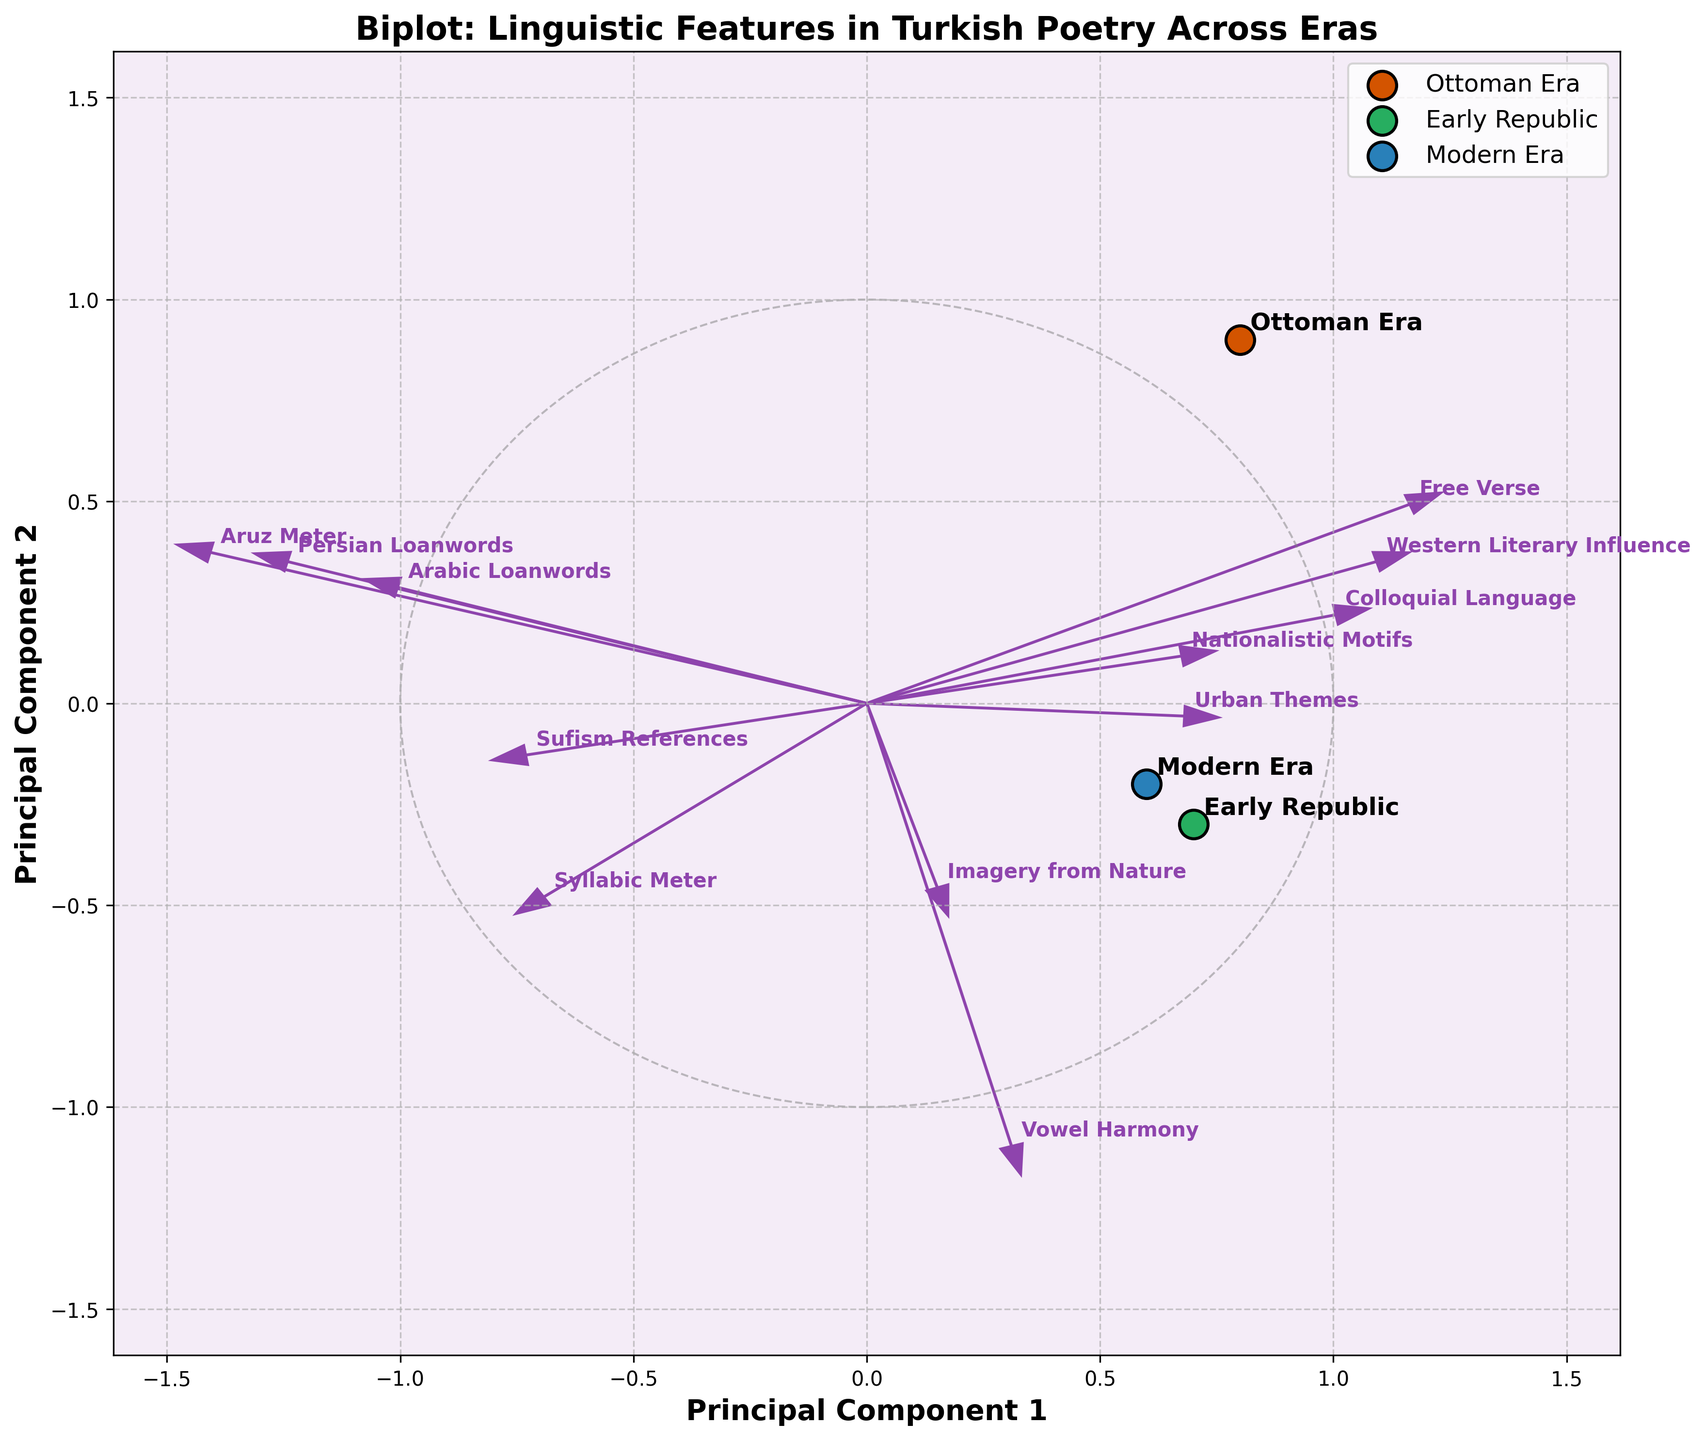What is the main title of the biplot? The main title is located at the top of the figure and is typically the most prominent text.
Answer: Biplot: Linguistic Features in Turkish Poetry Across Eras Which eras are represented by the three data points in the biplot? The three eras can be identified by looking at the labels near the large data points in the plot, marked by different colors.
Answer: Ottoman Era, Early Republic, Modern Era Which feature vector points in the direction of "Western Literary Influence"? The feature vectors are indicated by arrows, each labeled with a feature name. The "Western Literary Influence" arrow will point in a specific direction on the plot.
Answer: The arrow pointing towards the upper right quadrant Which era has the highest association with "Syllabic Meter"? To determine this, locate the data point for "Syllabic Meter" and see which era's data point is closest to it.
Answer: Ottoman Era How does "Urban Themes" change from the Ottoman Era to the Modern Era? Track the relative position of "Urban Themes" in respect to the Ottoman and Modern Era data points, indicated by its feature vector.
Answer: It increases, moving from a negative value in the Ottoman Era to a positive value in the Modern Era Which feature shows the most significant departure from traditional to modern times? Observe the lengths and directions of feature vectors to see which one moves most drastically from one end to another relative to the era points.
Answer: Aruz Meter What is the relationship between "Aruz Meter" and "Free Verse"? Compare the directions and positions of the arrows representing "Aruz Meter" and "Free Verse".
Answer: They are almost opposite; "Aruz Meter" decreases while "Free Verse" increases over time What are the principal components represented on the axes? The axes labels usually indicate the principal components; typically labeled as "Principal Component 1" and "Principal Component 2".
Answer: Principal Component 1 and Principal Component 2 Which features had a reduction in value from the Ottoman Era to the Early Republic? Identify the features whose arrows are closer to the Ottoman Era data point but move away from or become less aligned with the Early Republic data point.
Answer: Persian Loanwords, Arabic Loanwords, and Aruz Meter Which feature seems to be equally prominent in the Early Republic and Modern Era? Look for the feature vector that points towards, or is equidistant between, the Early Republic and Modern Era data points.
Answer: Colloquial Language 